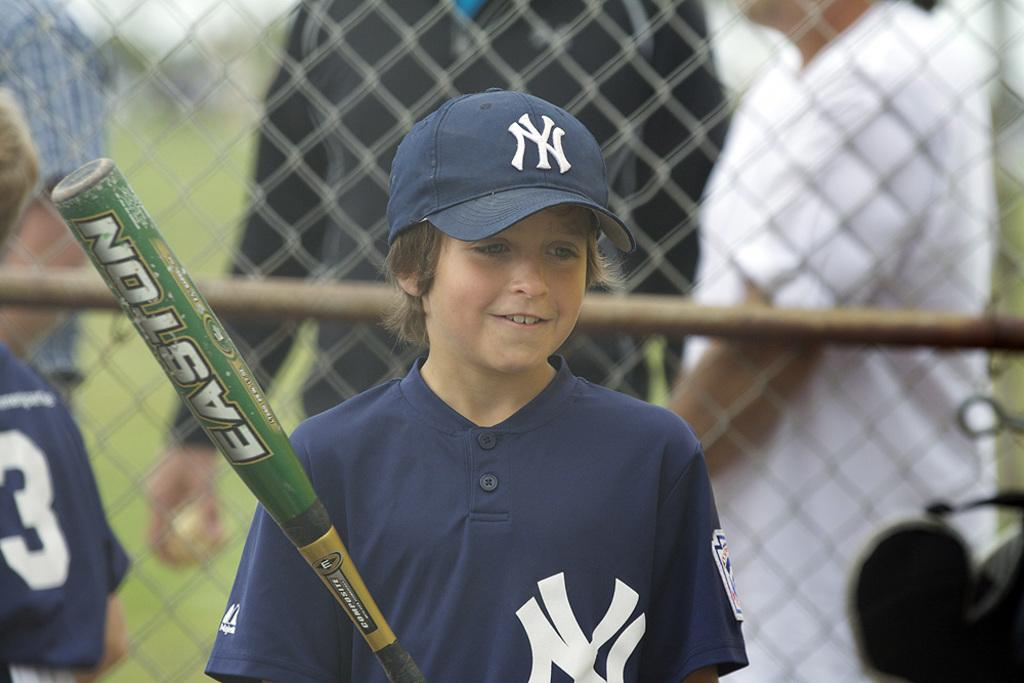<image>
Present a compact description of the photo's key features. Boy wearing a baseball jersey and holding a bat that says Easton on it. 